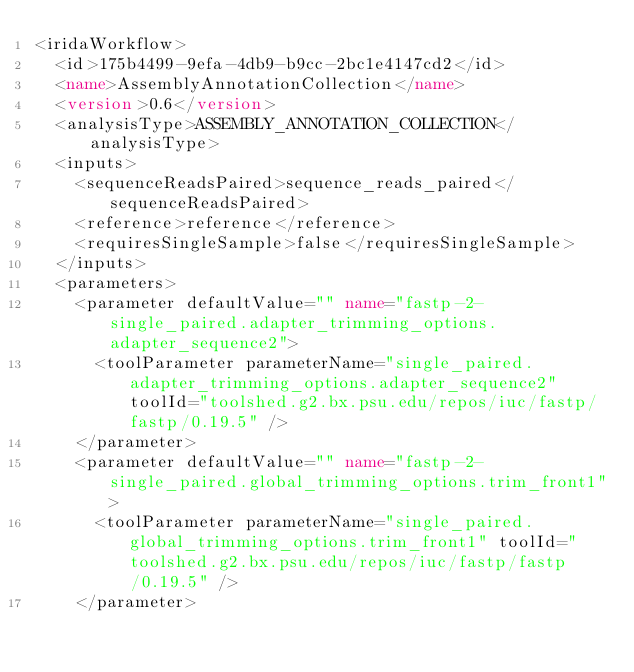<code> <loc_0><loc_0><loc_500><loc_500><_XML_><iridaWorkflow>
  <id>175b4499-9efa-4db9-b9cc-2bc1e4147cd2</id>
  <name>AssemblyAnnotationCollection</name>
  <version>0.6</version>
  <analysisType>ASSEMBLY_ANNOTATION_COLLECTION</analysisType>
  <inputs>
    <sequenceReadsPaired>sequence_reads_paired</sequenceReadsPaired>
    <reference>reference</reference>
    <requiresSingleSample>false</requiresSingleSample>
  </inputs>
  <parameters>
    <parameter defaultValue="" name="fastp-2-single_paired.adapter_trimming_options.adapter_sequence2">
      <toolParameter parameterName="single_paired.adapter_trimming_options.adapter_sequence2" toolId="toolshed.g2.bx.psu.edu/repos/iuc/fastp/fastp/0.19.5" />
    </parameter>
    <parameter defaultValue="" name="fastp-2-single_paired.global_trimming_options.trim_front1">
      <toolParameter parameterName="single_paired.global_trimming_options.trim_front1" toolId="toolshed.g2.bx.psu.edu/repos/iuc/fastp/fastp/0.19.5" />
    </parameter></code> 